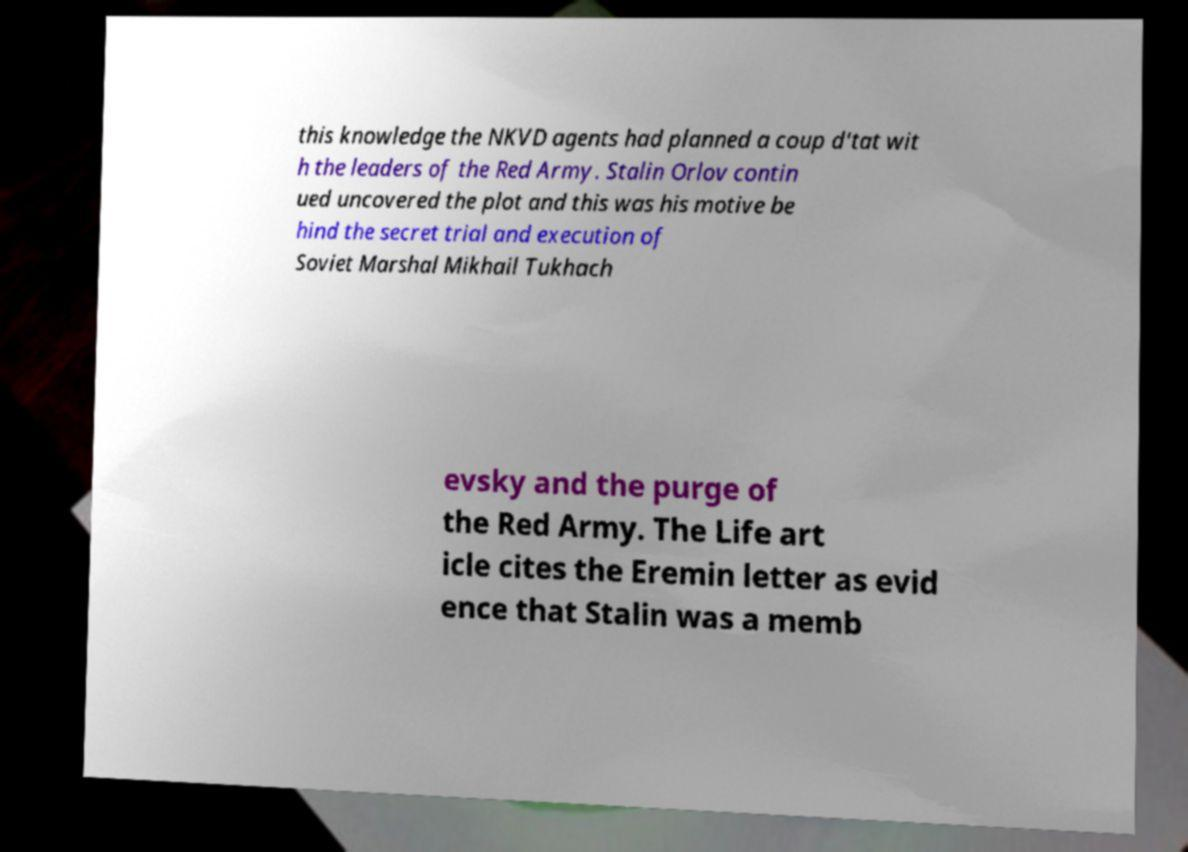What messages or text are displayed in this image? I need them in a readable, typed format. this knowledge the NKVD agents had planned a coup d'tat wit h the leaders of the Red Army. Stalin Orlov contin ued uncovered the plot and this was his motive be hind the secret trial and execution of Soviet Marshal Mikhail Tukhach evsky and the purge of the Red Army. The Life art icle cites the Eremin letter as evid ence that Stalin was a memb 